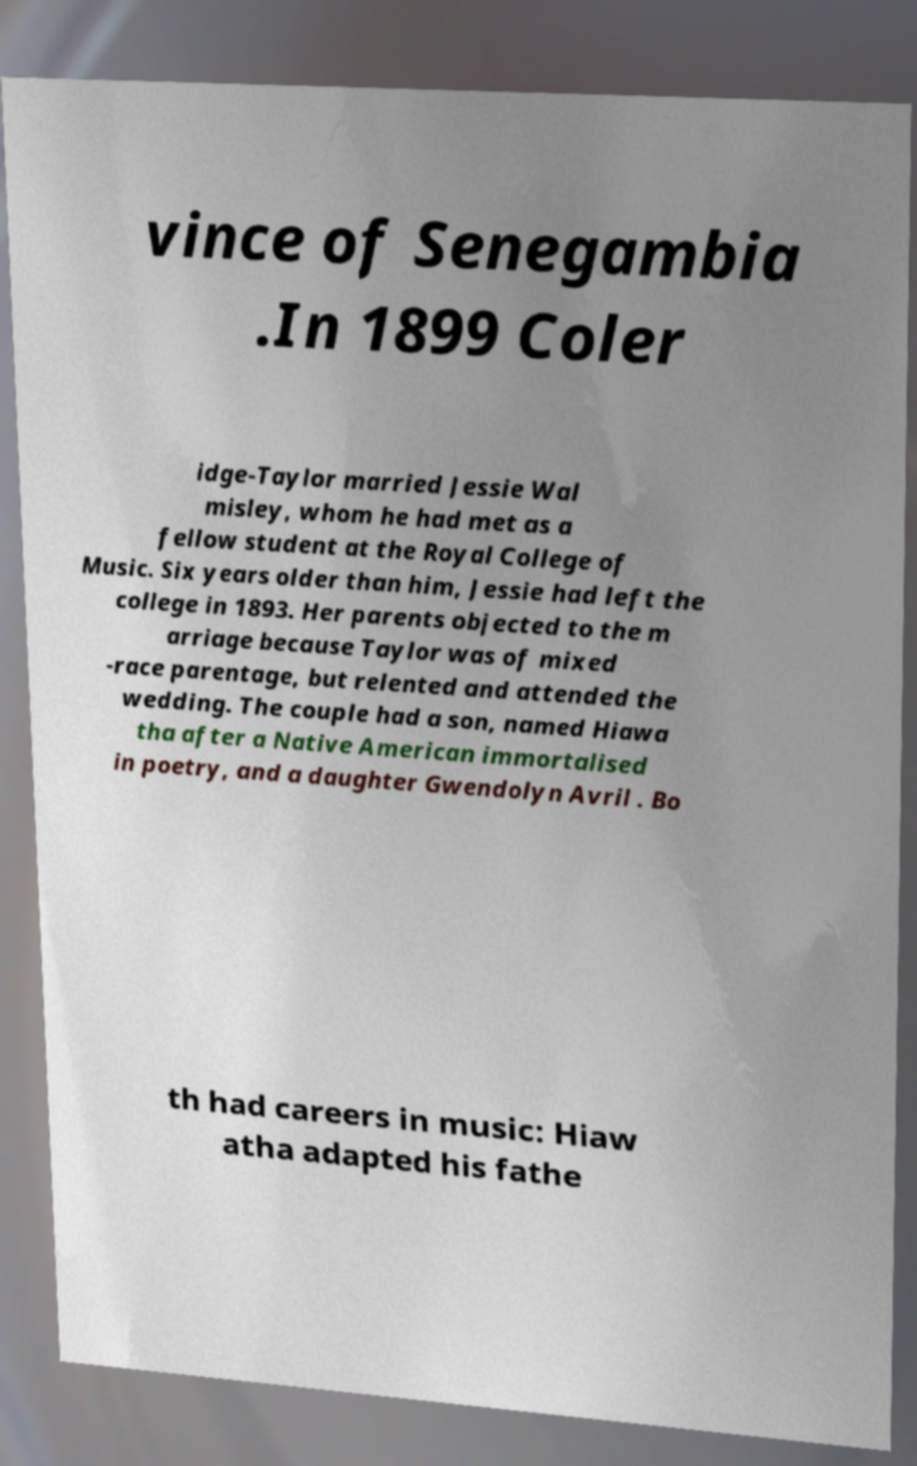Could you extract and type out the text from this image? vince of Senegambia .In 1899 Coler idge-Taylor married Jessie Wal misley, whom he had met as a fellow student at the Royal College of Music. Six years older than him, Jessie had left the college in 1893. Her parents objected to the m arriage because Taylor was of mixed -race parentage, but relented and attended the wedding. The couple had a son, named Hiawa tha after a Native American immortalised in poetry, and a daughter Gwendolyn Avril . Bo th had careers in music: Hiaw atha adapted his fathe 